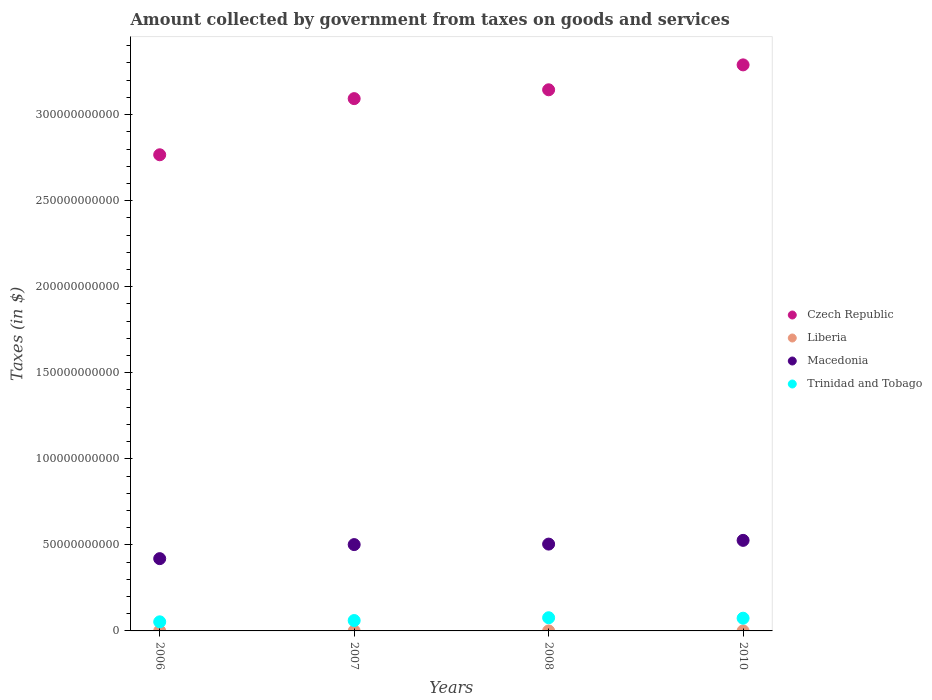How many different coloured dotlines are there?
Your answer should be very brief. 4. What is the amount collected by government from taxes on goods and services in Czech Republic in 2006?
Offer a terse response. 2.77e+11. Across all years, what is the maximum amount collected by government from taxes on goods and services in Czech Republic?
Your answer should be very brief. 3.29e+11. Across all years, what is the minimum amount collected by government from taxes on goods and services in Trinidad and Tobago?
Your answer should be very brief. 5.29e+09. In which year was the amount collected by government from taxes on goods and services in Liberia maximum?
Keep it short and to the point. 2010. In which year was the amount collected by government from taxes on goods and services in Trinidad and Tobago minimum?
Your answer should be compact. 2006. What is the total amount collected by government from taxes on goods and services in Macedonia in the graph?
Your answer should be very brief. 1.95e+11. What is the difference between the amount collected by government from taxes on goods and services in Trinidad and Tobago in 2007 and that in 2010?
Your answer should be very brief. -1.35e+09. What is the difference between the amount collected by government from taxes on goods and services in Trinidad and Tobago in 2006 and the amount collected by government from taxes on goods and services in Macedonia in 2010?
Offer a very short reply. -4.73e+1. What is the average amount collected by government from taxes on goods and services in Liberia per year?
Ensure brevity in your answer.  4.86e+05. In the year 2007, what is the difference between the amount collected by government from taxes on goods and services in Czech Republic and amount collected by government from taxes on goods and services in Trinidad and Tobago?
Offer a very short reply. 3.03e+11. In how many years, is the amount collected by government from taxes on goods and services in Czech Republic greater than 320000000000 $?
Provide a succinct answer. 1. What is the ratio of the amount collected by government from taxes on goods and services in Liberia in 2006 to that in 2007?
Your response must be concise. 0.8. What is the difference between the highest and the second highest amount collected by government from taxes on goods and services in Trinidad and Tobago?
Provide a short and direct response. 2.76e+08. What is the difference between the highest and the lowest amount collected by government from taxes on goods and services in Macedonia?
Provide a succinct answer. 1.06e+1. In how many years, is the amount collected by government from taxes on goods and services in Trinidad and Tobago greater than the average amount collected by government from taxes on goods and services in Trinidad and Tobago taken over all years?
Offer a terse response. 2. Is the amount collected by government from taxes on goods and services in Czech Republic strictly greater than the amount collected by government from taxes on goods and services in Trinidad and Tobago over the years?
Keep it short and to the point. Yes. How many years are there in the graph?
Provide a short and direct response. 4. Are the values on the major ticks of Y-axis written in scientific E-notation?
Give a very brief answer. No. Does the graph contain any zero values?
Provide a short and direct response. No. Does the graph contain grids?
Keep it short and to the point. No. Where does the legend appear in the graph?
Provide a succinct answer. Center right. How many legend labels are there?
Offer a terse response. 4. What is the title of the graph?
Offer a very short reply. Amount collected by government from taxes on goods and services. What is the label or title of the Y-axis?
Offer a very short reply. Taxes (in $). What is the Taxes (in $) in Czech Republic in 2006?
Provide a short and direct response. 2.77e+11. What is the Taxes (in $) in Liberia in 2006?
Your response must be concise. 3.50e+05. What is the Taxes (in $) in Macedonia in 2006?
Give a very brief answer. 4.20e+1. What is the Taxes (in $) in Trinidad and Tobago in 2006?
Your answer should be compact. 5.29e+09. What is the Taxes (in $) of Czech Republic in 2007?
Ensure brevity in your answer.  3.09e+11. What is the Taxes (in $) in Liberia in 2007?
Make the answer very short. 4.36e+05. What is the Taxes (in $) in Macedonia in 2007?
Provide a succinct answer. 5.02e+1. What is the Taxes (in $) of Trinidad and Tobago in 2007?
Give a very brief answer. 6.04e+09. What is the Taxes (in $) of Czech Republic in 2008?
Provide a succinct answer. 3.14e+11. What is the Taxes (in $) of Liberia in 2008?
Provide a short and direct response. 4.75e+05. What is the Taxes (in $) in Macedonia in 2008?
Provide a short and direct response. 5.04e+1. What is the Taxes (in $) of Trinidad and Tobago in 2008?
Provide a short and direct response. 7.66e+09. What is the Taxes (in $) in Czech Republic in 2010?
Provide a succinct answer. 3.29e+11. What is the Taxes (in $) of Liberia in 2010?
Offer a terse response. 6.83e+05. What is the Taxes (in $) of Macedonia in 2010?
Provide a short and direct response. 5.26e+1. What is the Taxes (in $) of Trinidad and Tobago in 2010?
Offer a terse response. 7.38e+09. Across all years, what is the maximum Taxes (in $) of Czech Republic?
Give a very brief answer. 3.29e+11. Across all years, what is the maximum Taxes (in $) in Liberia?
Keep it short and to the point. 6.83e+05. Across all years, what is the maximum Taxes (in $) in Macedonia?
Give a very brief answer. 5.26e+1. Across all years, what is the maximum Taxes (in $) in Trinidad and Tobago?
Provide a short and direct response. 7.66e+09. Across all years, what is the minimum Taxes (in $) in Czech Republic?
Your response must be concise. 2.77e+11. Across all years, what is the minimum Taxes (in $) in Liberia?
Make the answer very short. 3.50e+05. Across all years, what is the minimum Taxes (in $) of Macedonia?
Your answer should be compact. 4.20e+1. Across all years, what is the minimum Taxes (in $) of Trinidad and Tobago?
Your response must be concise. 5.29e+09. What is the total Taxes (in $) in Czech Republic in the graph?
Your answer should be compact. 1.23e+12. What is the total Taxes (in $) in Liberia in the graph?
Offer a very short reply. 1.94e+06. What is the total Taxes (in $) in Macedonia in the graph?
Your response must be concise. 1.95e+11. What is the total Taxes (in $) in Trinidad and Tobago in the graph?
Your answer should be compact. 2.64e+1. What is the difference between the Taxes (in $) in Czech Republic in 2006 and that in 2007?
Provide a short and direct response. -3.26e+1. What is the difference between the Taxes (in $) of Liberia in 2006 and that in 2007?
Provide a short and direct response. -8.60e+04. What is the difference between the Taxes (in $) in Macedonia in 2006 and that in 2007?
Keep it short and to the point. -8.17e+09. What is the difference between the Taxes (in $) of Trinidad and Tobago in 2006 and that in 2007?
Ensure brevity in your answer.  -7.52e+08. What is the difference between the Taxes (in $) in Czech Republic in 2006 and that in 2008?
Provide a succinct answer. -3.78e+1. What is the difference between the Taxes (in $) of Liberia in 2006 and that in 2008?
Ensure brevity in your answer.  -1.25e+05. What is the difference between the Taxes (in $) in Macedonia in 2006 and that in 2008?
Ensure brevity in your answer.  -8.45e+09. What is the difference between the Taxes (in $) of Trinidad and Tobago in 2006 and that in 2008?
Provide a succinct answer. -2.37e+09. What is the difference between the Taxes (in $) of Czech Republic in 2006 and that in 2010?
Provide a short and direct response. -5.22e+1. What is the difference between the Taxes (in $) of Liberia in 2006 and that in 2010?
Provide a succinct answer. -3.32e+05. What is the difference between the Taxes (in $) in Macedonia in 2006 and that in 2010?
Give a very brief answer. -1.06e+1. What is the difference between the Taxes (in $) in Trinidad and Tobago in 2006 and that in 2010?
Provide a succinct answer. -2.10e+09. What is the difference between the Taxes (in $) in Czech Republic in 2007 and that in 2008?
Your response must be concise. -5.13e+09. What is the difference between the Taxes (in $) of Liberia in 2007 and that in 2008?
Provide a succinct answer. -3.91e+04. What is the difference between the Taxes (in $) in Macedonia in 2007 and that in 2008?
Give a very brief answer. -2.87e+08. What is the difference between the Taxes (in $) in Trinidad and Tobago in 2007 and that in 2008?
Your response must be concise. -1.62e+09. What is the difference between the Taxes (in $) in Czech Republic in 2007 and that in 2010?
Keep it short and to the point. -1.96e+1. What is the difference between the Taxes (in $) in Liberia in 2007 and that in 2010?
Offer a very short reply. -2.46e+05. What is the difference between the Taxes (in $) in Macedonia in 2007 and that in 2010?
Offer a very short reply. -2.46e+09. What is the difference between the Taxes (in $) of Trinidad and Tobago in 2007 and that in 2010?
Make the answer very short. -1.35e+09. What is the difference between the Taxes (in $) in Czech Republic in 2008 and that in 2010?
Keep it short and to the point. -1.45e+1. What is the difference between the Taxes (in $) of Liberia in 2008 and that in 2010?
Offer a terse response. -2.07e+05. What is the difference between the Taxes (in $) of Macedonia in 2008 and that in 2010?
Provide a short and direct response. -2.17e+09. What is the difference between the Taxes (in $) in Trinidad and Tobago in 2008 and that in 2010?
Offer a terse response. 2.76e+08. What is the difference between the Taxes (in $) in Czech Republic in 2006 and the Taxes (in $) in Liberia in 2007?
Your answer should be very brief. 2.77e+11. What is the difference between the Taxes (in $) of Czech Republic in 2006 and the Taxes (in $) of Macedonia in 2007?
Make the answer very short. 2.27e+11. What is the difference between the Taxes (in $) in Czech Republic in 2006 and the Taxes (in $) in Trinidad and Tobago in 2007?
Make the answer very short. 2.71e+11. What is the difference between the Taxes (in $) in Liberia in 2006 and the Taxes (in $) in Macedonia in 2007?
Make the answer very short. -5.02e+1. What is the difference between the Taxes (in $) of Liberia in 2006 and the Taxes (in $) of Trinidad and Tobago in 2007?
Provide a succinct answer. -6.04e+09. What is the difference between the Taxes (in $) of Macedonia in 2006 and the Taxes (in $) of Trinidad and Tobago in 2007?
Your response must be concise. 3.60e+1. What is the difference between the Taxes (in $) of Czech Republic in 2006 and the Taxes (in $) of Liberia in 2008?
Provide a succinct answer. 2.77e+11. What is the difference between the Taxes (in $) of Czech Republic in 2006 and the Taxes (in $) of Macedonia in 2008?
Provide a succinct answer. 2.26e+11. What is the difference between the Taxes (in $) in Czech Republic in 2006 and the Taxes (in $) in Trinidad and Tobago in 2008?
Your response must be concise. 2.69e+11. What is the difference between the Taxes (in $) of Liberia in 2006 and the Taxes (in $) of Macedonia in 2008?
Give a very brief answer. -5.04e+1. What is the difference between the Taxes (in $) in Liberia in 2006 and the Taxes (in $) in Trinidad and Tobago in 2008?
Provide a short and direct response. -7.66e+09. What is the difference between the Taxes (in $) of Macedonia in 2006 and the Taxes (in $) of Trinidad and Tobago in 2008?
Provide a short and direct response. 3.43e+1. What is the difference between the Taxes (in $) of Czech Republic in 2006 and the Taxes (in $) of Liberia in 2010?
Ensure brevity in your answer.  2.77e+11. What is the difference between the Taxes (in $) of Czech Republic in 2006 and the Taxes (in $) of Macedonia in 2010?
Provide a succinct answer. 2.24e+11. What is the difference between the Taxes (in $) of Czech Republic in 2006 and the Taxes (in $) of Trinidad and Tobago in 2010?
Your answer should be compact. 2.69e+11. What is the difference between the Taxes (in $) of Liberia in 2006 and the Taxes (in $) of Macedonia in 2010?
Keep it short and to the point. -5.26e+1. What is the difference between the Taxes (in $) in Liberia in 2006 and the Taxes (in $) in Trinidad and Tobago in 2010?
Offer a terse response. -7.38e+09. What is the difference between the Taxes (in $) of Macedonia in 2006 and the Taxes (in $) of Trinidad and Tobago in 2010?
Offer a very short reply. 3.46e+1. What is the difference between the Taxes (in $) of Czech Republic in 2007 and the Taxes (in $) of Liberia in 2008?
Your answer should be very brief. 3.09e+11. What is the difference between the Taxes (in $) of Czech Republic in 2007 and the Taxes (in $) of Macedonia in 2008?
Your response must be concise. 2.59e+11. What is the difference between the Taxes (in $) in Czech Republic in 2007 and the Taxes (in $) in Trinidad and Tobago in 2008?
Ensure brevity in your answer.  3.02e+11. What is the difference between the Taxes (in $) of Liberia in 2007 and the Taxes (in $) of Macedonia in 2008?
Ensure brevity in your answer.  -5.04e+1. What is the difference between the Taxes (in $) of Liberia in 2007 and the Taxes (in $) of Trinidad and Tobago in 2008?
Make the answer very short. -7.66e+09. What is the difference between the Taxes (in $) of Macedonia in 2007 and the Taxes (in $) of Trinidad and Tobago in 2008?
Your answer should be compact. 4.25e+1. What is the difference between the Taxes (in $) of Czech Republic in 2007 and the Taxes (in $) of Liberia in 2010?
Ensure brevity in your answer.  3.09e+11. What is the difference between the Taxes (in $) of Czech Republic in 2007 and the Taxes (in $) of Macedonia in 2010?
Keep it short and to the point. 2.57e+11. What is the difference between the Taxes (in $) in Czech Republic in 2007 and the Taxes (in $) in Trinidad and Tobago in 2010?
Provide a succinct answer. 3.02e+11. What is the difference between the Taxes (in $) of Liberia in 2007 and the Taxes (in $) of Macedonia in 2010?
Offer a terse response. -5.26e+1. What is the difference between the Taxes (in $) of Liberia in 2007 and the Taxes (in $) of Trinidad and Tobago in 2010?
Provide a short and direct response. -7.38e+09. What is the difference between the Taxes (in $) of Macedonia in 2007 and the Taxes (in $) of Trinidad and Tobago in 2010?
Ensure brevity in your answer.  4.28e+1. What is the difference between the Taxes (in $) in Czech Republic in 2008 and the Taxes (in $) in Liberia in 2010?
Make the answer very short. 3.14e+11. What is the difference between the Taxes (in $) of Czech Republic in 2008 and the Taxes (in $) of Macedonia in 2010?
Ensure brevity in your answer.  2.62e+11. What is the difference between the Taxes (in $) in Czech Republic in 2008 and the Taxes (in $) in Trinidad and Tobago in 2010?
Offer a terse response. 3.07e+11. What is the difference between the Taxes (in $) in Liberia in 2008 and the Taxes (in $) in Macedonia in 2010?
Make the answer very short. -5.26e+1. What is the difference between the Taxes (in $) of Liberia in 2008 and the Taxes (in $) of Trinidad and Tobago in 2010?
Your response must be concise. -7.38e+09. What is the difference between the Taxes (in $) of Macedonia in 2008 and the Taxes (in $) of Trinidad and Tobago in 2010?
Keep it short and to the point. 4.31e+1. What is the average Taxes (in $) in Czech Republic per year?
Offer a very short reply. 3.07e+11. What is the average Taxes (in $) of Liberia per year?
Your answer should be compact. 4.86e+05. What is the average Taxes (in $) of Macedonia per year?
Make the answer very short. 4.88e+1. What is the average Taxes (in $) of Trinidad and Tobago per year?
Your answer should be compact. 6.59e+09. In the year 2006, what is the difference between the Taxes (in $) in Czech Republic and Taxes (in $) in Liberia?
Keep it short and to the point. 2.77e+11. In the year 2006, what is the difference between the Taxes (in $) of Czech Republic and Taxes (in $) of Macedonia?
Offer a terse response. 2.35e+11. In the year 2006, what is the difference between the Taxes (in $) of Czech Republic and Taxes (in $) of Trinidad and Tobago?
Keep it short and to the point. 2.71e+11. In the year 2006, what is the difference between the Taxes (in $) in Liberia and Taxes (in $) in Macedonia?
Offer a terse response. -4.20e+1. In the year 2006, what is the difference between the Taxes (in $) in Liberia and Taxes (in $) in Trinidad and Tobago?
Make the answer very short. -5.29e+09. In the year 2006, what is the difference between the Taxes (in $) in Macedonia and Taxes (in $) in Trinidad and Tobago?
Provide a short and direct response. 3.67e+1. In the year 2007, what is the difference between the Taxes (in $) in Czech Republic and Taxes (in $) in Liberia?
Ensure brevity in your answer.  3.09e+11. In the year 2007, what is the difference between the Taxes (in $) of Czech Republic and Taxes (in $) of Macedonia?
Your answer should be very brief. 2.59e+11. In the year 2007, what is the difference between the Taxes (in $) of Czech Republic and Taxes (in $) of Trinidad and Tobago?
Provide a short and direct response. 3.03e+11. In the year 2007, what is the difference between the Taxes (in $) of Liberia and Taxes (in $) of Macedonia?
Offer a very short reply. -5.02e+1. In the year 2007, what is the difference between the Taxes (in $) in Liberia and Taxes (in $) in Trinidad and Tobago?
Provide a short and direct response. -6.04e+09. In the year 2007, what is the difference between the Taxes (in $) of Macedonia and Taxes (in $) of Trinidad and Tobago?
Give a very brief answer. 4.41e+1. In the year 2008, what is the difference between the Taxes (in $) in Czech Republic and Taxes (in $) in Liberia?
Offer a terse response. 3.14e+11. In the year 2008, what is the difference between the Taxes (in $) in Czech Republic and Taxes (in $) in Macedonia?
Provide a succinct answer. 2.64e+11. In the year 2008, what is the difference between the Taxes (in $) of Czech Republic and Taxes (in $) of Trinidad and Tobago?
Your response must be concise. 3.07e+11. In the year 2008, what is the difference between the Taxes (in $) of Liberia and Taxes (in $) of Macedonia?
Provide a succinct answer. -5.04e+1. In the year 2008, what is the difference between the Taxes (in $) in Liberia and Taxes (in $) in Trinidad and Tobago?
Your answer should be very brief. -7.66e+09. In the year 2008, what is the difference between the Taxes (in $) of Macedonia and Taxes (in $) of Trinidad and Tobago?
Ensure brevity in your answer.  4.28e+1. In the year 2010, what is the difference between the Taxes (in $) of Czech Republic and Taxes (in $) of Liberia?
Your answer should be very brief. 3.29e+11. In the year 2010, what is the difference between the Taxes (in $) of Czech Republic and Taxes (in $) of Macedonia?
Make the answer very short. 2.76e+11. In the year 2010, what is the difference between the Taxes (in $) of Czech Republic and Taxes (in $) of Trinidad and Tobago?
Provide a succinct answer. 3.22e+11. In the year 2010, what is the difference between the Taxes (in $) in Liberia and Taxes (in $) in Macedonia?
Offer a very short reply. -5.26e+1. In the year 2010, what is the difference between the Taxes (in $) of Liberia and Taxes (in $) of Trinidad and Tobago?
Provide a short and direct response. -7.38e+09. In the year 2010, what is the difference between the Taxes (in $) in Macedonia and Taxes (in $) in Trinidad and Tobago?
Provide a short and direct response. 4.52e+1. What is the ratio of the Taxes (in $) of Czech Republic in 2006 to that in 2007?
Offer a terse response. 0.89. What is the ratio of the Taxes (in $) in Liberia in 2006 to that in 2007?
Offer a very short reply. 0.8. What is the ratio of the Taxes (in $) in Macedonia in 2006 to that in 2007?
Your answer should be compact. 0.84. What is the ratio of the Taxes (in $) in Trinidad and Tobago in 2006 to that in 2007?
Offer a terse response. 0.88. What is the ratio of the Taxes (in $) in Czech Republic in 2006 to that in 2008?
Provide a succinct answer. 0.88. What is the ratio of the Taxes (in $) of Liberia in 2006 to that in 2008?
Provide a succinct answer. 0.74. What is the ratio of the Taxes (in $) of Macedonia in 2006 to that in 2008?
Offer a very short reply. 0.83. What is the ratio of the Taxes (in $) in Trinidad and Tobago in 2006 to that in 2008?
Give a very brief answer. 0.69. What is the ratio of the Taxes (in $) of Czech Republic in 2006 to that in 2010?
Provide a succinct answer. 0.84. What is the ratio of the Taxes (in $) in Liberia in 2006 to that in 2010?
Provide a succinct answer. 0.51. What is the ratio of the Taxes (in $) of Macedonia in 2006 to that in 2010?
Offer a very short reply. 0.8. What is the ratio of the Taxes (in $) of Trinidad and Tobago in 2006 to that in 2010?
Provide a succinct answer. 0.72. What is the ratio of the Taxes (in $) in Czech Republic in 2007 to that in 2008?
Provide a short and direct response. 0.98. What is the ratio of the Taxes (in $) of Liberia in 2007 to that in 2008?
Your response must be concise. 0.92. What is the ratio of the Taxes (in $) of Macedonia in 2007 to that in 2008?
Offer a terse response. 0.99. What is the ratio of the Taxes (in $) of Trinidad and Tobago in 2007 to that in 2008?
Offer a terse response. 0.79. What is the ratio of the Taxes (in $) of Czech Republic in 2007 to that in 2010?
Offer a terse response. 0.94. What is the ratio of the Taxes (in $) of Liberia in 2007 to that in 2010?
Provide a short and direct response. 0.64. What is the ratio of the Taxes (in $) of Macedonia in 2007 to that in 2010?
Your response must be concise. 0.95. What is the ratio of the Taxes (in $) in Trinidad and Tobago in 2007 to that in 2010?
Provide a short and direct response. 0.82. What is the ratio of the Taxes (in $) in Czech Republic in 2008 to that in 2010?
Ensure brevity in your answer.  0.96. What is the ratio of the Taxes (in $) in Liberia in 2008 to that in 2010?
Provide a short and direct response. 0.7. What is the ratio of the Taxes (in $) of Macedonia in 2008 to that in 2010?
Ensure brevity in your answer.  0.96. What is the ratio of the Taxes (in $) in Trinidad and Tobago in 2008 to that in 2010?
Offer a terse response. 1.04. What is the difference between the highest and the second highest Taxes (in $) of Czech Republic?
Provide a short and direct response. 1.45e+1. What is the difference between the highest and the second highest Taxes (in $) of Liberia?
Ensure brevity in your answer.  2.07e+05. What is the difference between the highest and the second highest Taxes (in $) of Macedonia?
Give a very brief answer. 2.17e+09. What is the difference between the highest and the second highest Taxes (in $) of Trinidad and Tobago?
Offer a terse response. 2.76e+08. What is the difference between the highest and the lowest Taxes (in $) of Czech Republic?
Give a very brief answer. 5.22e+1. What is the difference between the highest and the lowest Taxes (in $) in Liberia?
Provide a succinct answer. 3.32e+05. What is the difference between the highest and the lowest Taxes (in $) of Macedonia?
Ensure brevity in your answer.  1.06e+1. What is the difference between the highest and the lowest Taxes (in $) in Trinidad and Tobago?
Give a very brief answer. 2.37e+09. 